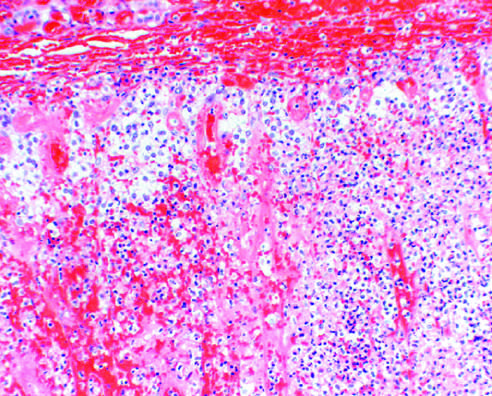what is discernible in this photomicrograph?
Answer the question using a single word or phrase. Little residual cortical architecture 